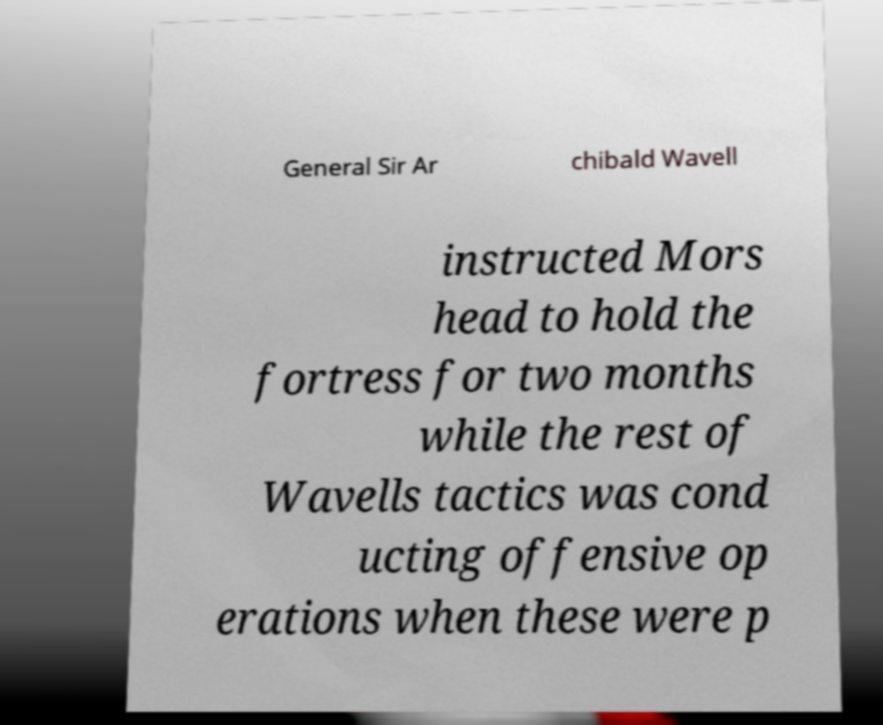There's text embedded in this image that I need extracted. Can you transcribe it verbatim? General Sir Ar chibald Wavell instructed Mors head to hold the fortress for two months while the rest of Wavells tactics was cond ucting offensive op erations when these were p 